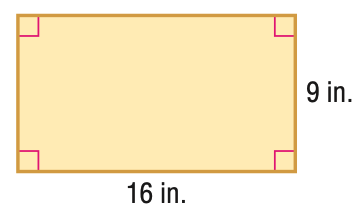Answer the mathemtical geometry problem and directly provide the correct option letter.
Question: Find the perimeter of the figure.
Choices: A: 25 B: 50 C: 100 D: 144 B 